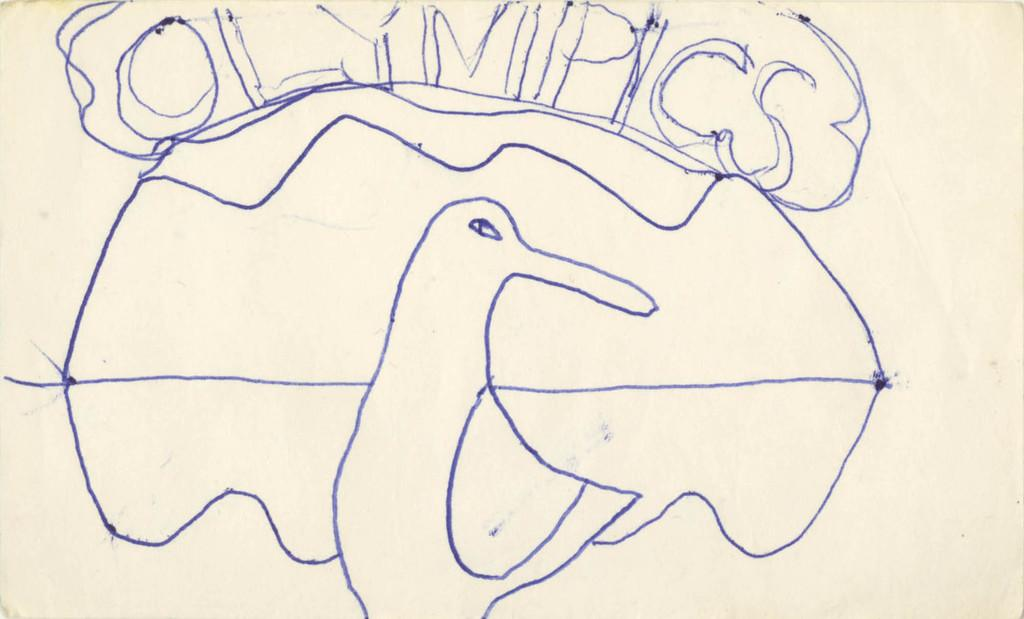What is the medium of the image? The image is on a paper. What is depicted in the image? There is a sketch of a bird in the image. Are there any words or letters in the image? Yes, there is text in the image. How much money is visible in the image? There is no money present in the image; it features a sketch of a bird and text. What type of fog can be seen in the image? There is no fog present in the image; it is a sketch of a bird on a paper with text. 